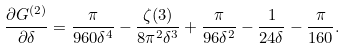Convert formula to latex. <formula><loc_0><loc_0><loc_500><loc_500>\frac { \partial G ^ { ( 2 ) } } { \partial \delta } = \frac { \pi } { 9 6 0 \delta ^ { 4 } } - \frac { \zeta ( 3 ) } { 8 \pi ^ { 2 } \delta ^ { 3 } } + \frac { \pi } { 9 6 \delta ^ { 2 } } - \frac { 1 } { 2 4 \delta } - \frac { \pi } { 1 6 0 } .</formula> 